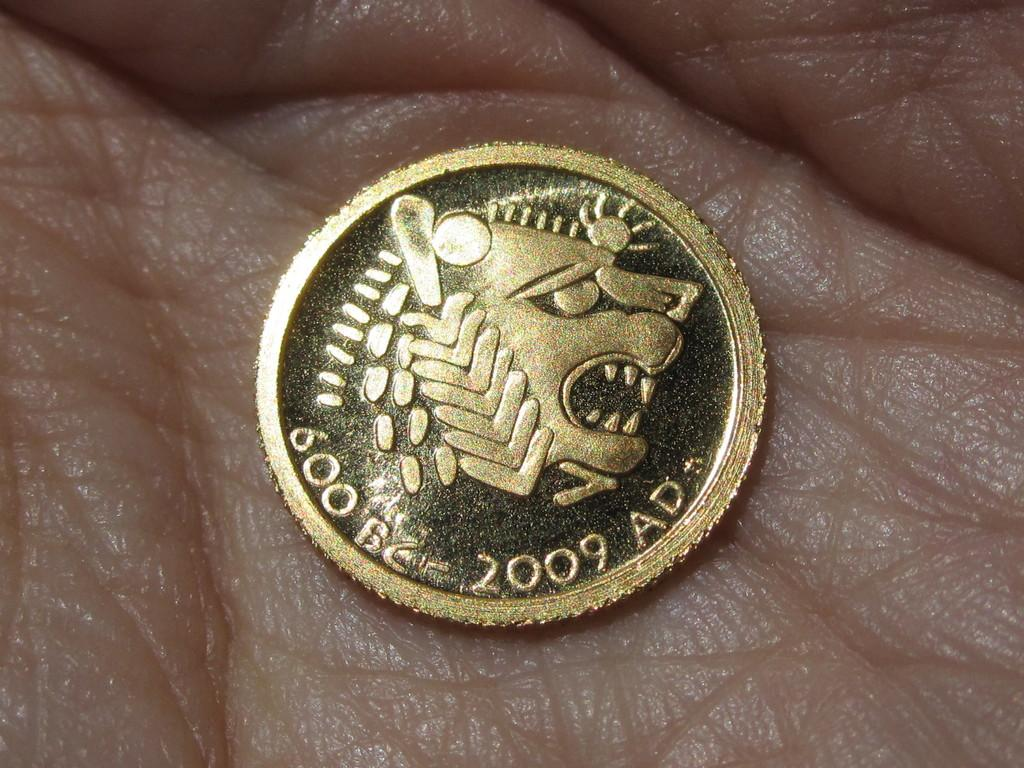Provide a one-sentence caption for the provided image. A hand holds a coin that reads 600 BC and 2009 AD. 